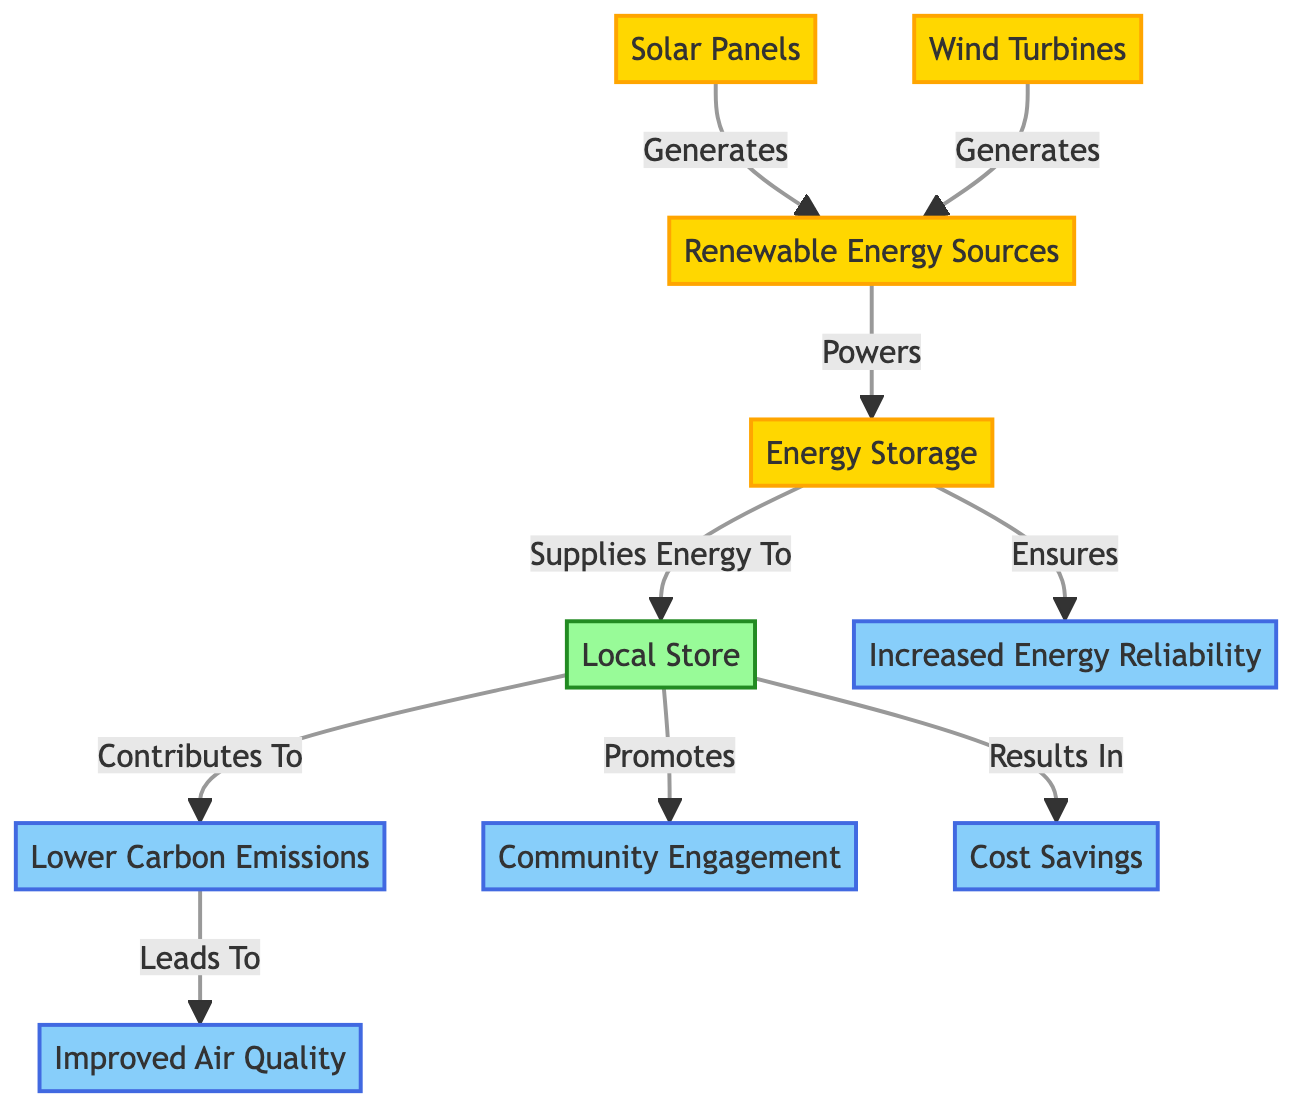What are the two sources that generate renewable energy? The diagram shows "Solar Panels" and "Wind Turbines" as two sources that generate renewable energy, indicated by arrows pointing towards "Renewable Energy Sources".
Answer: Solar Panels, Wind Turbines What does "Energy Storage" supply energy to? The diagram depicts a direct connection from "Energy Storage" to "Local Store", which indicates that energy storage supplies energy specifically to the local store.
Answer: Local Store How many different benefits are listed in the diagram? The diagram has five benefits listed: "Lower Carbon Emissions," "Improved Air Quality," "Cost Savings," "Increased Energy Reliability," and "Community Engagement." Counting these nodes gives a total of five benefits.
Answer: 5 What is the relationship between "Local Store" and "Lower Carbon Emissions"? The diagram shows a direct connection from "Local Store" to "Lower Carbon Emissions", indicating that the local store contributes to lowering carbon emissions.
Answer: Contributes To Which benefit is directly linked to "Lower Carbon Emissions"? The diagram clearly indicates that "Lower Carbon Emissions" leads to "Improved Air Quality," establishing a direct relationship between the two benefits.
Answer: Improved Air Quality What ensures "Increased Energy Reliability"? According to the flow of the diagram, "Energy Storage" is the node that ensures increased reliability, as noted by the connection leading from energy storage to this benefit.
Answer: Energy Storage What role does the "Local Store" play in "Community Engagement"? The diagram shows a directed link from "Local Store" to "Community Engagement," suggesting that the local store promotes community engagement within the neighborhood.
Answer: Promotes How does the "Energy Storage" influence "Increased Energy Reliability"? The diagram shows that "Energy Storage" ensures increased energy reliability, indicating that without energy storage, the reliability of energy supply could be compromised.
Answer: Ensures 